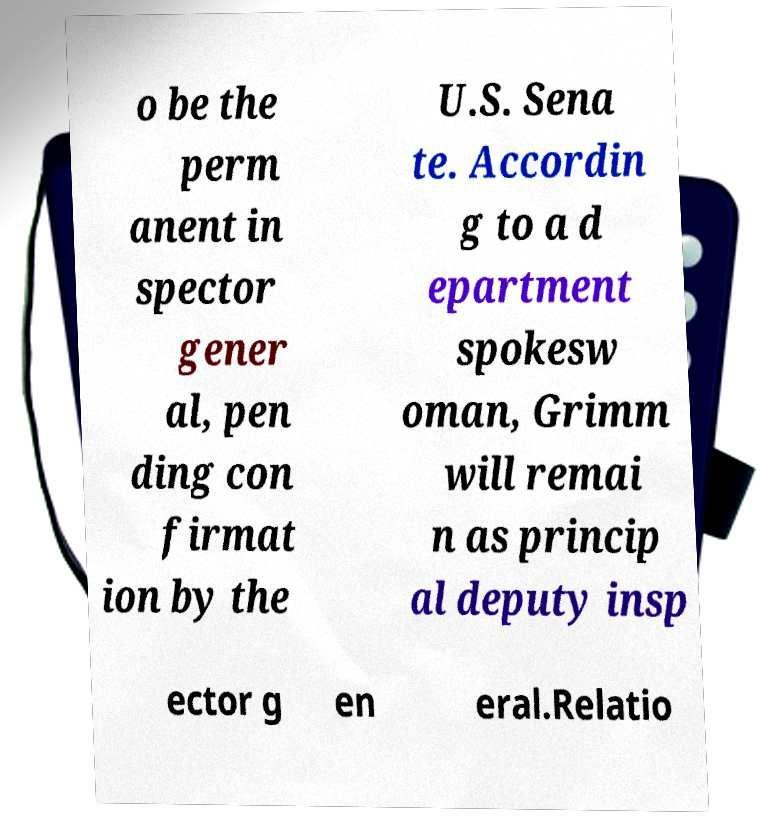There's text embedded in this image that I need extracted. Can you transcribe it verbatim? o be the perm anent in spector gener al, pen ding con firmat ion by the U.S. Sena te. Accordin g to a d epartment spokesw oman, Grimm will remai n as princip al deputy insp ector g en eral.Relatio 